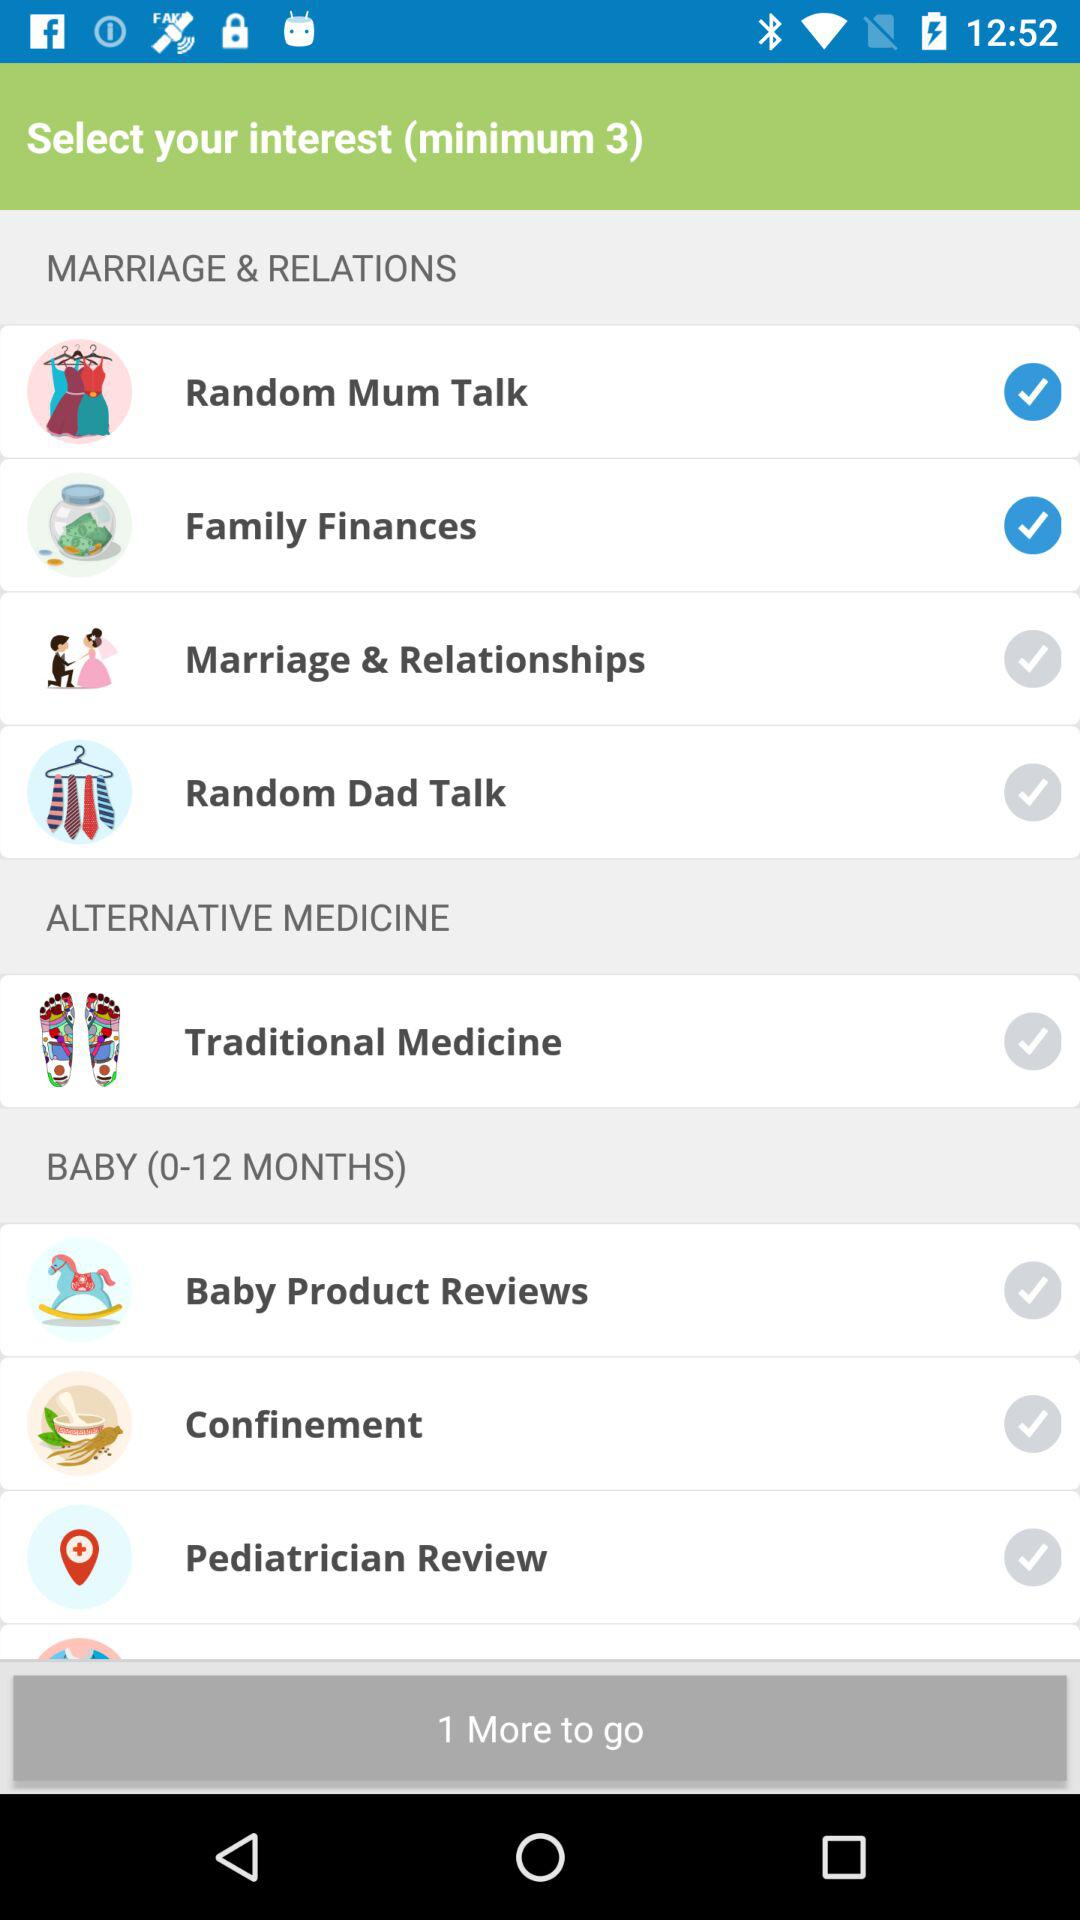What is the duration left?
When the provided information is insufficient, respond with <no answer>. <no answer> 